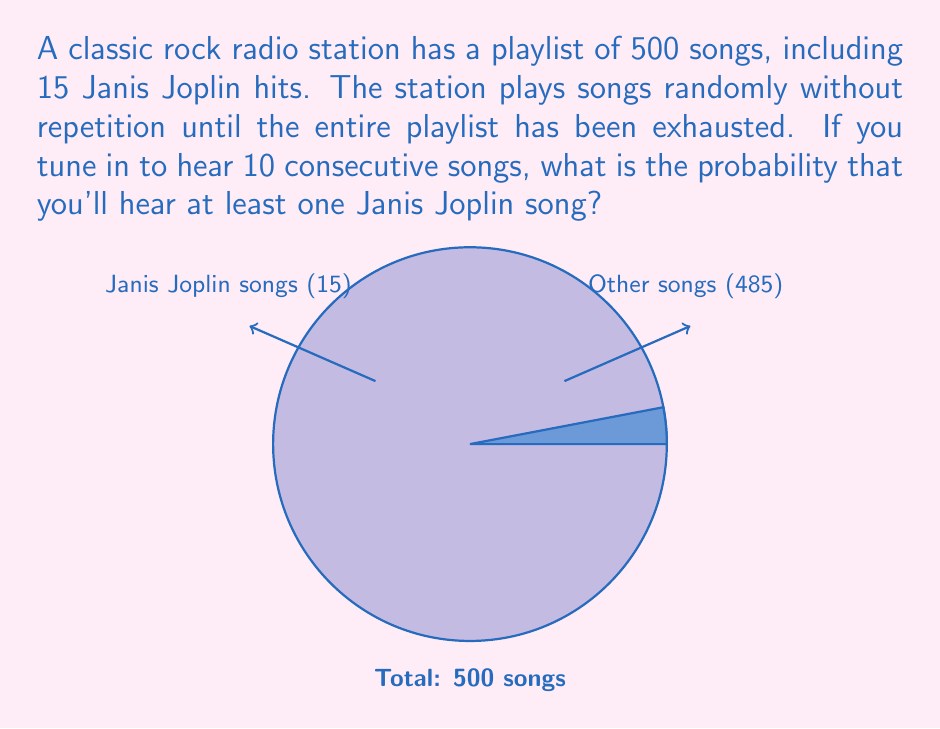Can you solve this math problem? Let's approach this step-by-step:

1) First, let's calculate the probability of not hearing a Janis Joplin song in a single play:
   $$P(\text{no Janis}) = \frac{485}{500} = 0.97$$

2) For 10 consecutive plays, we need the probability of not hearing Janis Joplin 10 times in a row:
   $$P(\text{no Janis in 10 plays}) = (0.97)^{10} \approx 0.7374$$

3) The probability of hearing at least one Janis Joplin song is the complement of hearing no Janis Joplin songs:
   $$P(\text{at least one Janis}) = 1 - P(\text{no Janis in 10 plays})$$
   $$= 1 - 0.7374 = 0.2626$$

4) Convert to a percentage:
   $$0.2626 \times 100\% = 26.26\%$$

Therefore, the probability of hearing at least one Janis Joplin song in 10 consecutive plays is approximately 26.26%.
Answer: 26.26% 